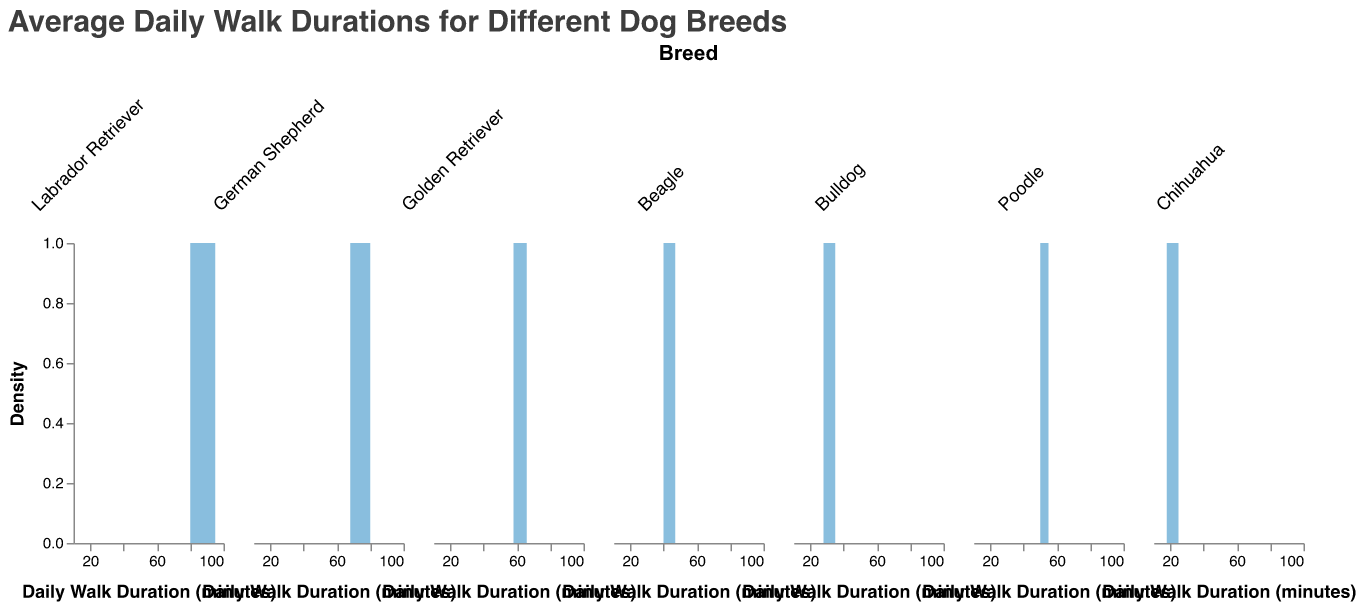What is the title of the plot? The title of the plot is usually at the top and is meant to give an overview of what the plot represents.
Answer: Average Daily Walk Durations for Different Dog Breeds What are the breeds included in the plot? The breeds included are labeled at the top of each subplot column and are rotated for easy reading.
Answer: Labrador Retriever, German Shepherd, Golden Retriever, Beagle, Bulldog, Poodle, Chihuahua What is the x-axis label? The x-axis label provides information about what the horizontal axis measures.
Answer: Daily Walk Duration (minutes) Which breed of dog has the highest range of daily walk durations? By comparing the spread of the density plots for all breeds, you can identify which breed's plot covers the widest range on the x-axis.
Answer: Labrador Retriever Which breed of dog has the lowest range of daily walk durations? By comparing the spread of the density plots for all breeds, you can identify which breed's plot covers the narrowest range on the x-axis.
Answer: Chihuahua Which breed has the peak density at the longest walk duration? By locating the highest point (peak) of each density curve and comparing their positions on the x-axis, you can identify the breed.
Answer: Labrador Retriever How do the walk durations for Beagles compare to those for Bulldogs? Compare the positions and spreads of the density plots for Beagles and Bulldogs to analyze their durations.
Answer: Beagles have longer walk durations compared to Bulldogs What is the general trend of walk durations from Labradors to Chihuahuas? By looking at the density plots from left to right, observe the changes in densities and average positions along the x-axis.
Answer: The trend shows decreasing walk durations from Labradors to Chihuahuas Which breed has its highest peak around 65 minutes? Find which density plot has its highest point (peak) around the 65-minute mark on the x-axis.
Answer: Golden Retriever How do the densities of walk durations for Labradors and Poodles compare? Compare the shapes and peaks of the density plots of Labradors and Poodles to understand differences in walk durations.
Answer: Labradors have a broader spread and higher peak compared to Poodles 